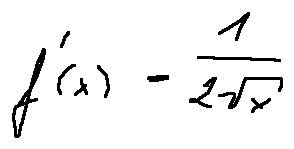Convert formula to latex. <formula><loc_0><loc_0><loc_500><loc_500>f ^ { \prime } ( x ) = \frac { 1 } { 2 \sqrt { x } }</formula> 